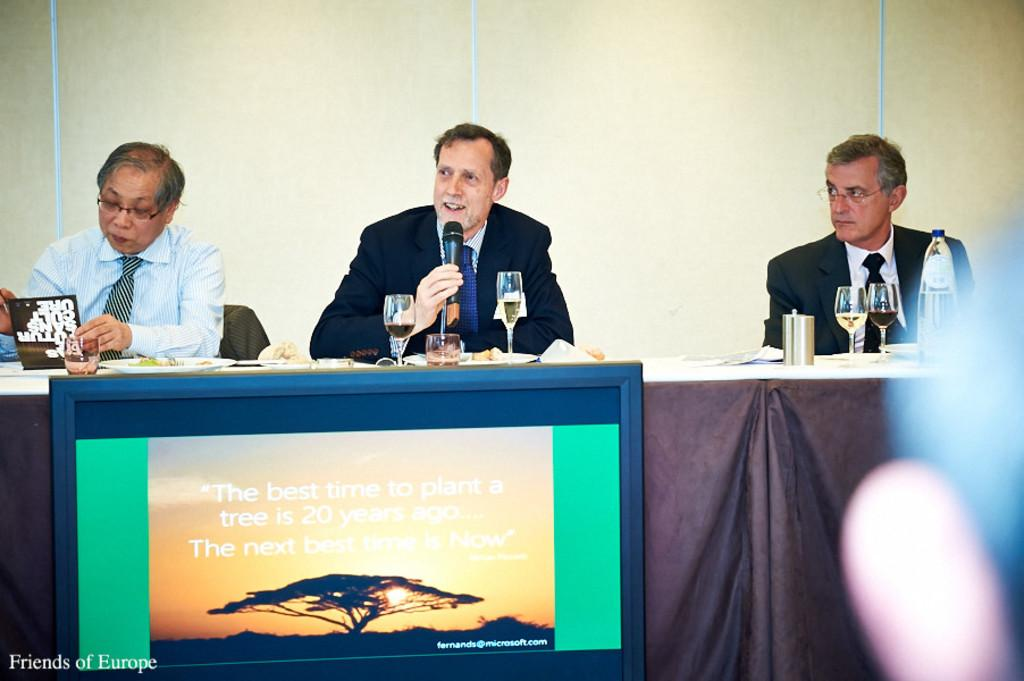<image>
Offer a succinct explanation of the picture presented. men at a table and in front of them is sign with a tree on it  and some of the words on sign are the next 